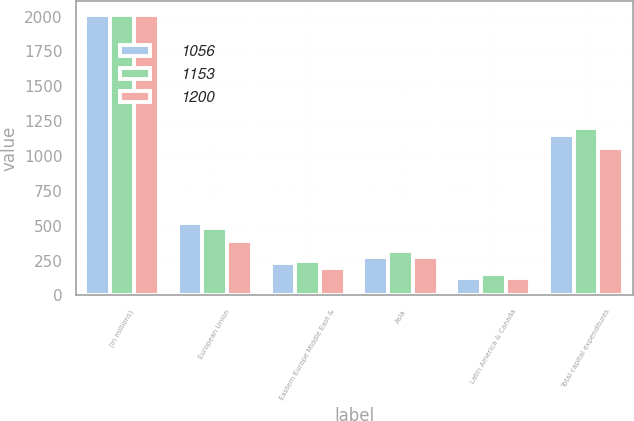<chart> <loc_0><loc_0><loc_500><loc_500><stacked_bar_chart><ecel><fcel>(in millions)<fcel>European Union<fcel>Eastern Europe Middle East &<fcel>Asia<fcel>Latin America & Canada<fcel>Total capital expenditures<nl><fcel>1056<fcel>2014<fcel>519<fcel>234<fcel>272<fcel>125<fcel>1153<nl><fcel>1153<fcel>2013<fcel>480<fcel>247<fcel>317<fcel>156<fcel>1200<nl><fcel>1200<fcel>2012<fcel>391<fcel>197<fcel>277<fcel>127<fcel>1056<nl></chart> 